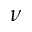<formula> <loc_0><loc_0><loc_500><loc_500>\nu</formula> 